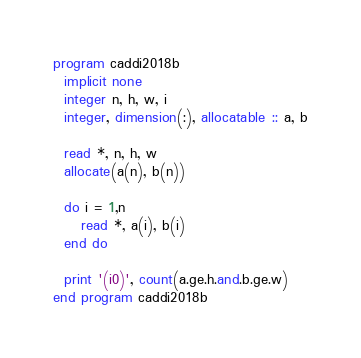Convert code to text. <code><loc_0><loc_0><loc_500><loc_500><_FORTRAN_>program caddi2018b
  implicit none
  integer n, h, w, i
  integer, dimension(:), allocatable :: a, b

  read *, n, h, w
  allocate(a(n), b(n))

  do i = 1,n
     read *, a(i), b(i)
  end do

  print '(i0)', count(a.ge.h.and.b.ge.w)
end program caddi2018b
</code> 